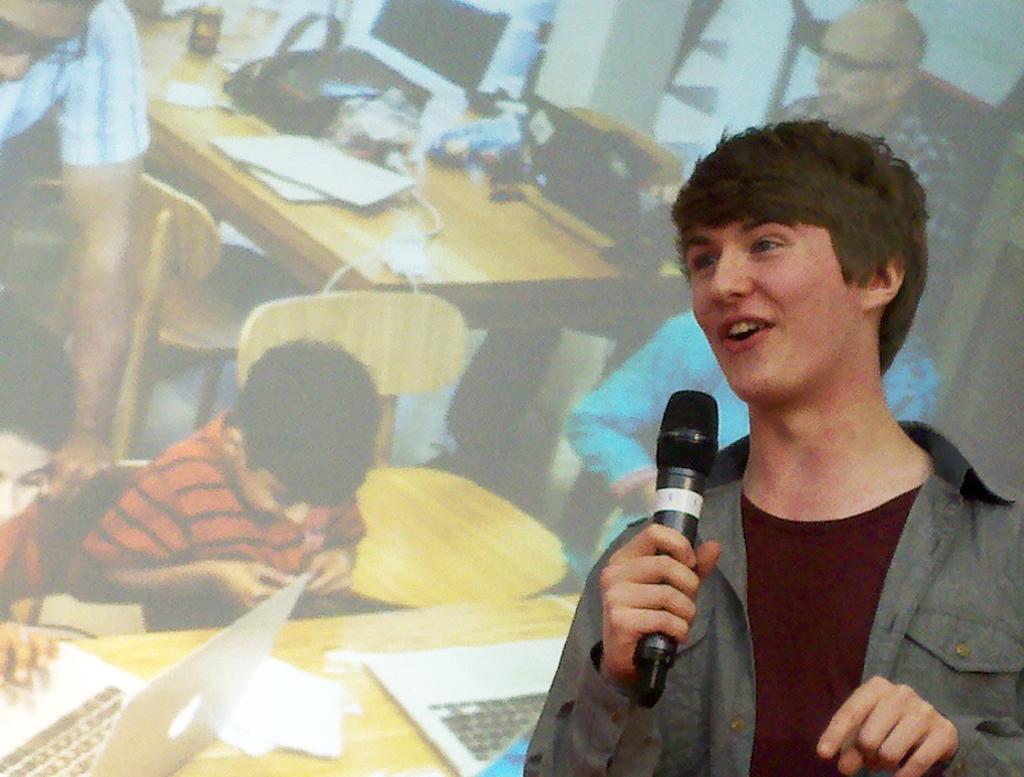Could you give a brief overview of what you see in this image? In the picture we can find a boy holding a microphone and he is smiling, he is wearing a grey shirt and T-shirt. In the background we can find some table, chairs and one boy and two persons. 